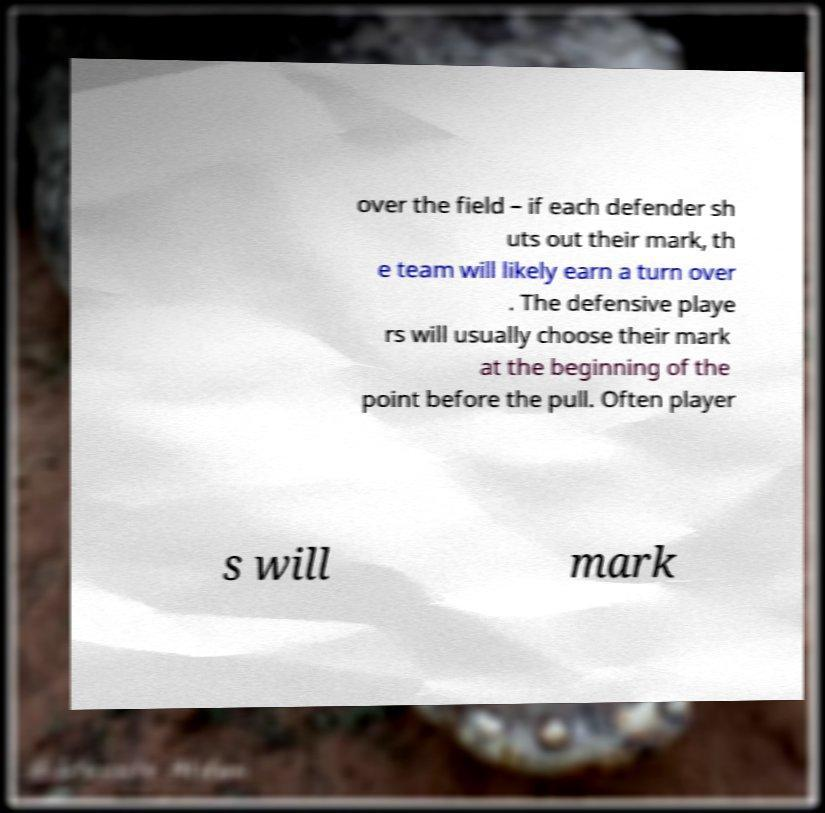For documentation purposes, I need the text within this image transcribed. Could you provide that? over the field – if each defender sh uts out their mark, th e team will likely earn a turn over . The defensive playe rs will usually choose their mark at the beginning of the point before the pull. Often player s will mark 